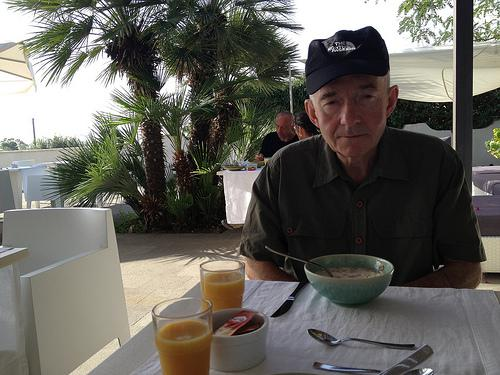Question: where was this photo taken?
Choices:
A. At a store.
B. At the bank.
C. At an outside restaurant.
D. In a hospital.
Answer with the letter. Answer: C Question: why is this photo illuminated?
Choices:
A. Flash.
B. Lamp.
C. Sunlight.
D. Outside photo.
Answer with the letter. Answer: C Question: what color is the juice?
Choices:
A. Purple.
B. Orange.
C. Blue.
D. Green.
Answer with the letter. Answer: B Question: who is the subject of the photo?
Choices:
A. The girl.
B. The woman.
C. The boy.
D. The man.
Answer with the letter. Answer: D 